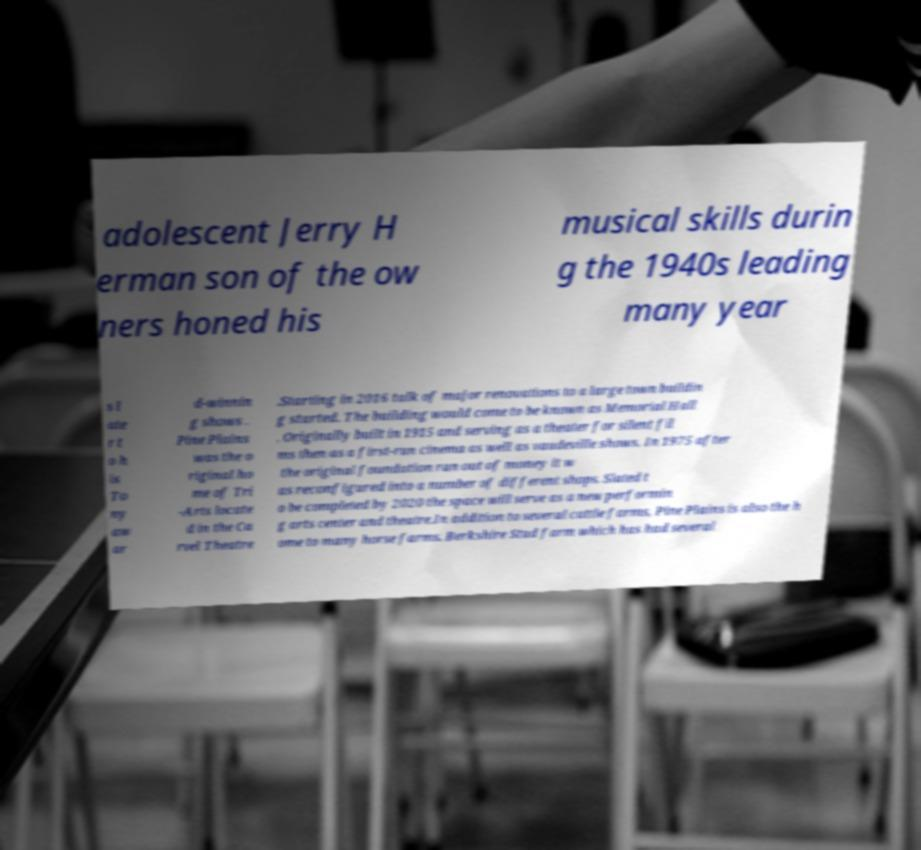Can you accurately transcribe the text from the provided image for me? adolescent Jerry H erman son of the ow ners honed his musical skills durin g the 1940s leading many year s l ate r t o h is To ny aw ar d-winnin g shows . Pine Plains was the o riginal ho me of Tri -Arts locate d in the Ca rvel Theatre .Starting in 2016 talk of major renovations to a large town buildin g started. The building would come to be known as Memorial Hall . Originally built in 1915 and serving as a theater for silent fil ms then as a first-run cinema as well as vaudeville shows. In 1975 after the original foundation ran out of money it w as reconfigured into a number of different shops. Slated t o be completed by 2020 the space will serve as a new performin g arts center and theatre.In addition to several cattle farms, Pine Plains is also the h ome to many horse farms. Berkshire Stud farm which has had several 